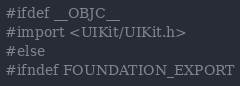<code> <loc_0><loc_0><loc_500><loc_500><_C_>#ifdef __OBJC__
#import <UIKit/UIKit.h>
#else
#ifndef FOUNDATION_EXPORT</code> 